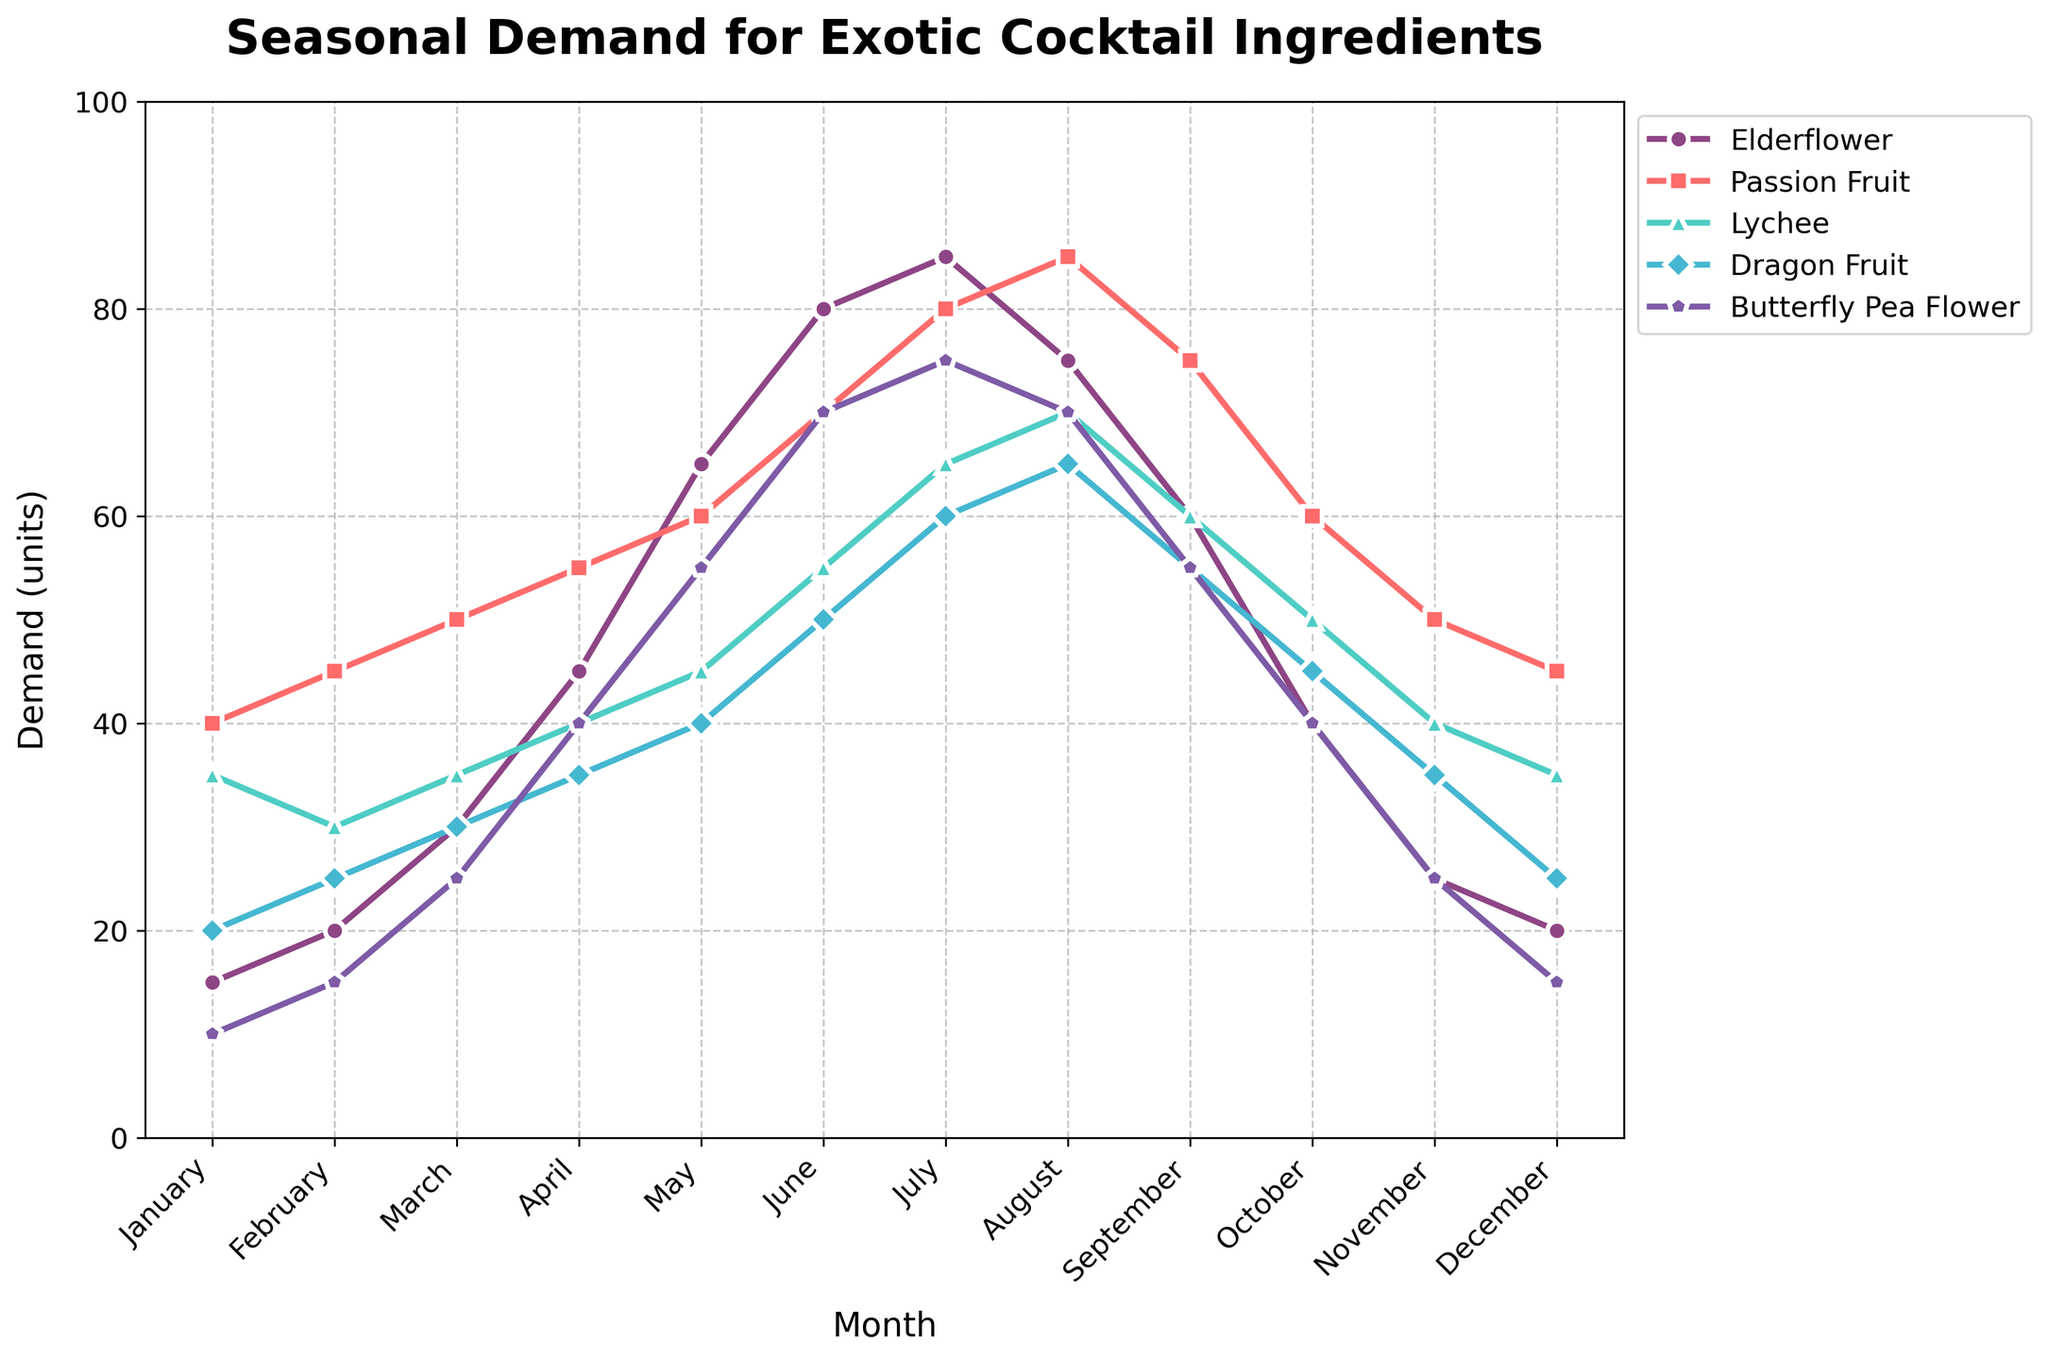What is the trend of demand for Elderflower from January to December? The plot shows the demand for Elderflower across each month from January to December. By observing the purple line with circular markers, starting from January at approximately 15 units, it shows a generally increasing trend, peaking in July at around 85 units, then decreasing towards December back to around 20 units.
Answer: Demand increases to July then decreases During which month is the demand for Dragon Fruit the highest? By following the teal line with triangle markers on the plot, the highest demand for Dragon Fruit appears in August, where the line reaches its peak at about 65 units.
Answer: August Which ingredient shows the most stable demand throughout the year? Observing the lines on the plot, Butterfly Pea Flower (represented by the purple line with star markers) appears most stable. It shows an increase in demand but does not fluctuate as sharply as the other ingredients.
Answer: Butterfly Pea Flower Compare the demand for Passion Fruit in March with the demand for Lychee in September. Which is higher? Looking at the red line with square markers for Passion Fruit in March, the demand is around 50 units. For Lychee in September, represented by the green line with diamond markers, the demand is around 60 units. The demand for Lychee in September is higher.
Answer: Lychee in September What is the average demand for Passion Fruit from January to December? Summing up the monthly demands for Passion Fruit: 40 + 45 + 50 + 55 + 60 + 70 + 80 + 85 + 75 + 60 + 50 + 45 = 715 units. Dividing by 12 months gives an average of approximately 59.6 units.
Answer: 59.6 units Which ingredient has the greatest increase in demand from January to July? Calculating the increase for each ingredient: 
- Elderflower: 85 - 15 = 70
- Passion Fruit: 80 - 40 = 40
- Lychee: 65 - 35 = 30
- Dragon Fruit: 60 - 20 = 40
- Butterfly Pea Flower: 75 - 10 = 65
Elderflower shows the greatest increase of 70 units.
Answer: Elderflower Which ingredient's demand reaches its peak the earliest in the year? Observing the peaks of the lines, Elderflower and Dragon Fruit peak in July, Passion Fruit in August, Lychee and Butterfly Pea Flower in July. Thus, all reach their peak in July.
Answer: Elderflower, Dragon Fruit, Lychee, and Butterfly Pea Flower Is there any month where all ingredients show increasing demand compared to the previous month? By examining the lines month-by-month, from February to March, all ingredients' demand increases over their January to February values – Elderflower from 15 to 20, Passion Fruit from 40 to 45, Lychee remaining steady at 35, Dragon Fruit from 20 to 25, and Butterfly Pea Flower from 10 to 15.
Answer: March 